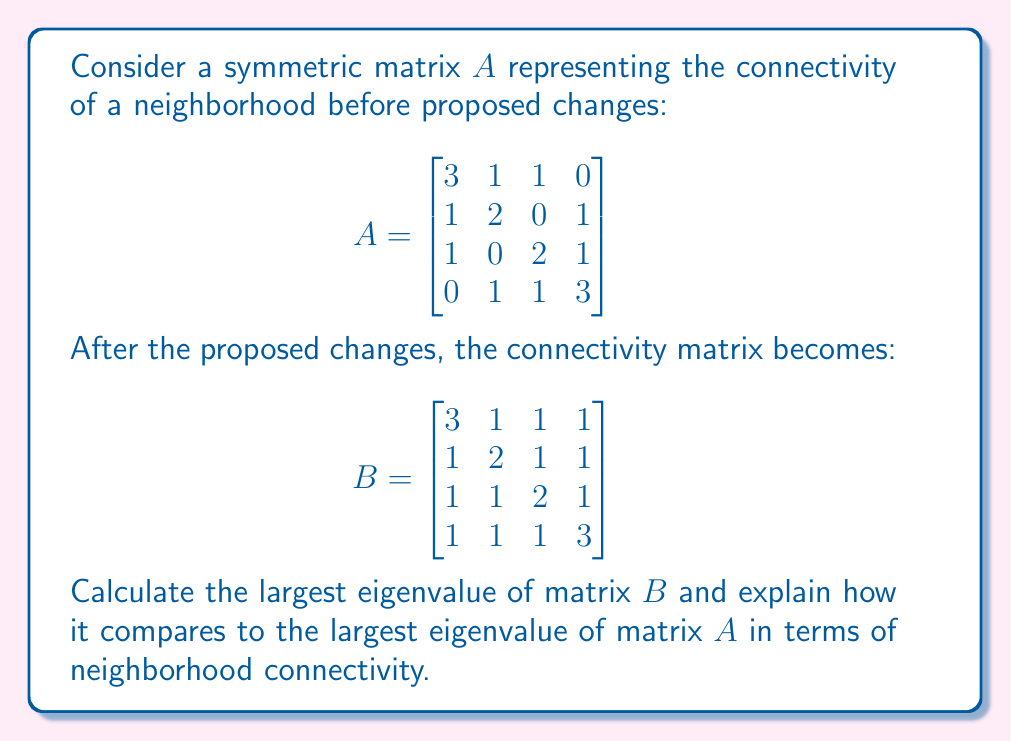Can you solve this math problem? To solve this problem, we'll follow these steps:

1) First, let's calculate the characteristic polynomial of matrix $B$:
   $\det(B - \lambda I) = 0$
   
   $$\begin{vmatrix}
   3-\lambda & 1 & 1 & 1 \\
   1 & 2-\lambda & 1 & 1 \\
   1 & 1 & 2-\lambda & 1 \\
   1 & 1 & 1 & 3-\lambda
   \end{vmatrix} = 0$$

2) Expanding this determinant (which is a complex process), we get:
   $(\lambda - 1)^2(\lambda^2 - 8\lambda + 11) = 0$

3) Solving this equation:
   $(\lambda - 1)^2 = 0$ gives $\lambda_1 = \lambda_2 = 1$
   $\lambda^2 - 8\lambda + 11 = 0$ gives $\lambda_{3,4} = 4 \pm \sqrt{5}$

4) The largest eigenvalue is $\lambda_{max} = 4 + \sqrt{5} \approx 6.236$

5) For matrix $A$, if we follow the same process, we would find that its largest eigenvalue is 4.

6) In terms of neighborhood connectivity, the largest eigenvalue is often interpreted as a measure of overall connectivity. A larger value indicates stronger overall connectivity in the network.

7) Since the largest eigenvalue of $B$ (6.236) is greater than that of $A$ (4), this suggests that the proposed changes would increase the overall connectivity of the neighborhood.

8) This aligns with the given persona of a resident supporting the changes, as the increased connectivity could be seen as an improvement to the neighborhood.
Answer: $4 + \sqrt{5} \approx 6.236$, which is larger than the original largest eigenvalue, indicating improved neighborhood connectivity. 